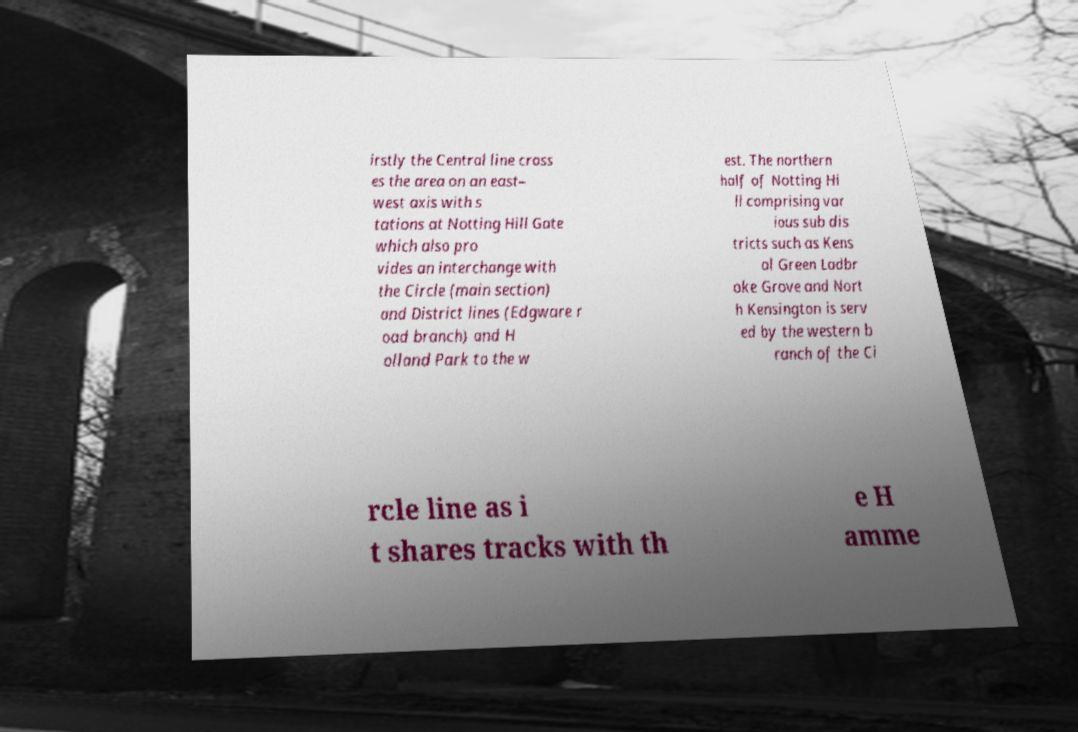Please identify and transcribe the text found in this image. irstly the Central line cross es the area on an east– west axis with s tations at Notting Hill Gate which also pro vides an interchange with the Circle (main section) and District lines (Edgware r oad branch) and H olland Park to the w est. The northern half of Notting Hi ll comprising var ious sub dis tricts such as Kens al Green Ladbr oke Grove and Nort h Kensington is serv ed by the western b ranch of the Ci rcle line as i t shares tracks with th e H amme 